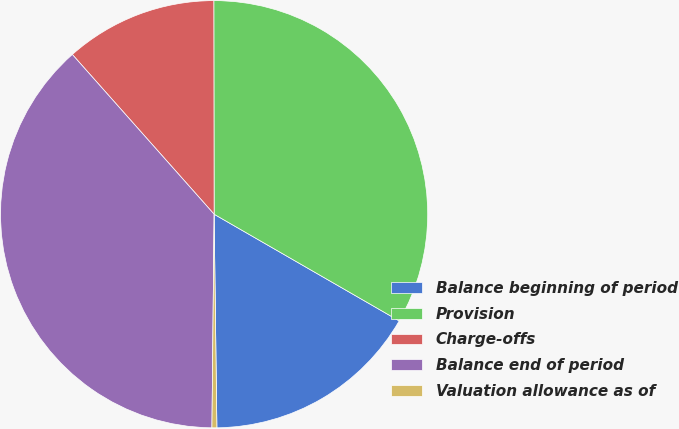Convert chart to OTSL. <chart><loc_0><loc_0><loc_500><loc_500><pie_chart><fcel>Balance beginning of period<fcel>Provision<fcel>Charge-offs<fcel>Balance end of period<fcel>Valuation allowance as of<nl><fcel>16.47%<fcel>33.34%<fcel>11.53%<fcel>38.28%<fcel>0.37%<nl></chart> 